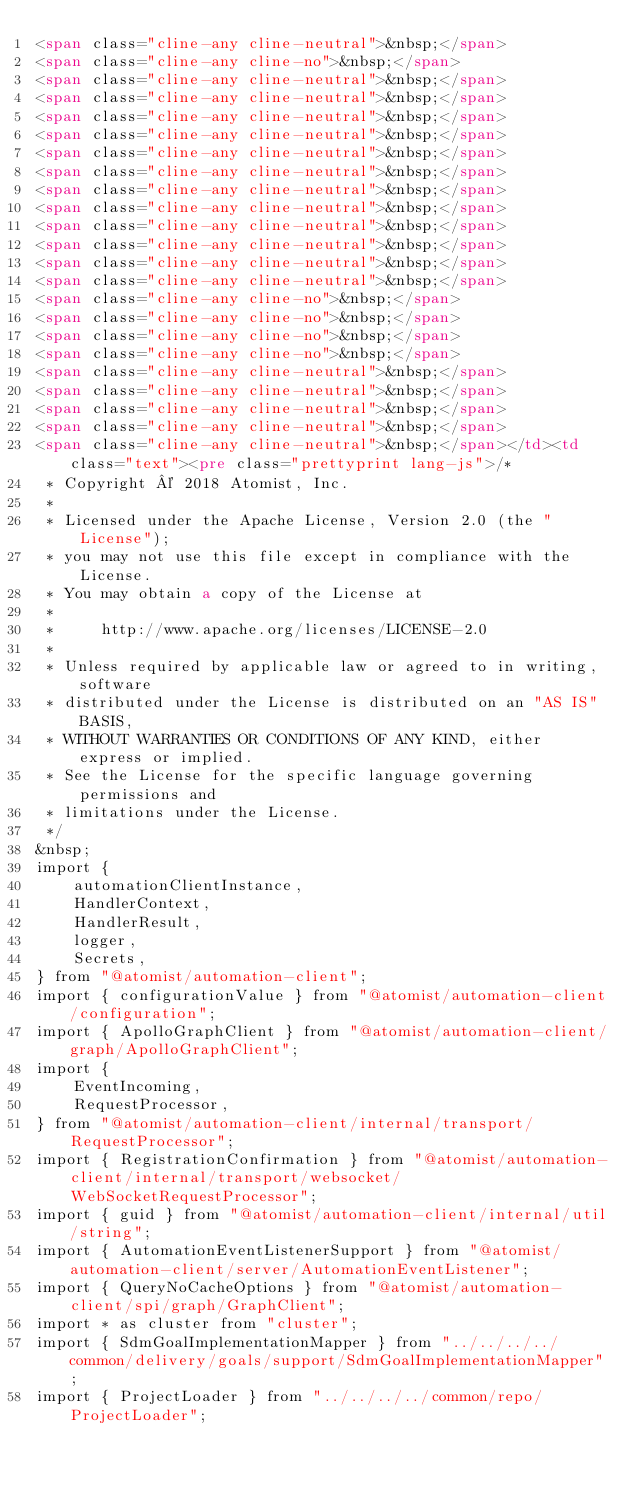Convert code to text. <code><loc_0><loc_0><loc_500><loc_500><_HTML_><span class="cline-any cline-neutral">&nbsp;</span>
<span class="cline-any cline-no">&nbsp;</span>
<span class="cline-any cline-neutral">&nbsp;</span>
<span class="cline-any cline-neutral">&nbsp;</span>
<span class="cline-any cline-neutral">&nbsp;</span>
<span class="cline-any cline-neutral">&nbsp;</span>
<span class="cline-any cline-neutral">&nbsp;</span>
<span class="cline-any cline-neutral">&nbsp;</span>
<span class="cline-any cline-neutral">&nbsp;</span>
<span class="cline-any cline-neutral">&nbsp;</span>
<span class="cline-any cline-neutral">&nbsp;</span>
<span class="cline-any cline-neutral">&nbsp;</span>
<span class="cline-any cline-neutral">&nbsp;</span>
<span class="cline-any cline-neutral">&nbsp;</span>
<span class="cline-any cline-no">&nbsp;</span>
<span class="cline-any cline-no">&nbsp;</span>
<span class="cline-any cline-no">&nbsp;</span>
<span class="cline-any cline-no">&nbsp;</span>
<span class="cline-any cline-neutral">&nbsp;</span>
<span class="cline-any cline-neutral">&nbsp;</span>
<span class="cline-any cline-neutral">&nbsp;</span>
<span class="cline-any cline-neutral">&nbsp;</span>
<span class="cline-any cline-neutral">&nbsp;</span></td><td class="text"><pre class="prettyprint lang-js">/*
 * Copyright © 2018 Atomist, Inc.
 *
 * Licensed under the Apache License, Version 2.0 (the "License");
 * you may not use this file except in compliance with the License.
 * You may obtain a copy of the License at
 *
 *     http://www.apache.org/licenses/LICENSE-2.0
 *
 * Unless required by applicable law or agreed to in writing, software
 * distributed under the License is distributed on an "AS IS" BASIS,
 * WITHOUT WARRANTIES OR CONDITIONS OF ANY KIND, either express or implied.
 * See the License for the specific language governing permissions and
 * limitations under the License.
 */
&nbsp;
import {
    automationClientInstance,
    HandlerContext,
    HandlerResult,
    logger,
    Secrets,
} from "@atomist/automation-client";
import { configurationValue } from "@atomist/automation-client/configuration";
import { ApolloGraphClient } from "@atomist/automation-client/graph/ApolloGraphClient";
import {
    EventIncoming,
    RequestProcessor,
} from "@atomist/automation-client/internal/transport/RequestProcessor";
import { RegistrationConfirmation } from "@atomist/automation-client/internal/transport/websocket/WebSocketRequestProcessor";
import { guid } from "@atomist/automation-client/internal/util/string";
import { AutomationEventListenerSupport } from "@atomist/automation-client/server/AutomationEventListener";
import { QueryNoCacheOptions } from "@atomist/automation-client/spi/graph/GraphClient";
import * as cluster from "cluster";
import { SdmGoalImplementationMapper } from "../../../../common/delivery/goals/support/SdmGoalImplementationMapper";
import { ProjectLoader } from "../../../../common/repo/ProjectLoader";</code> 